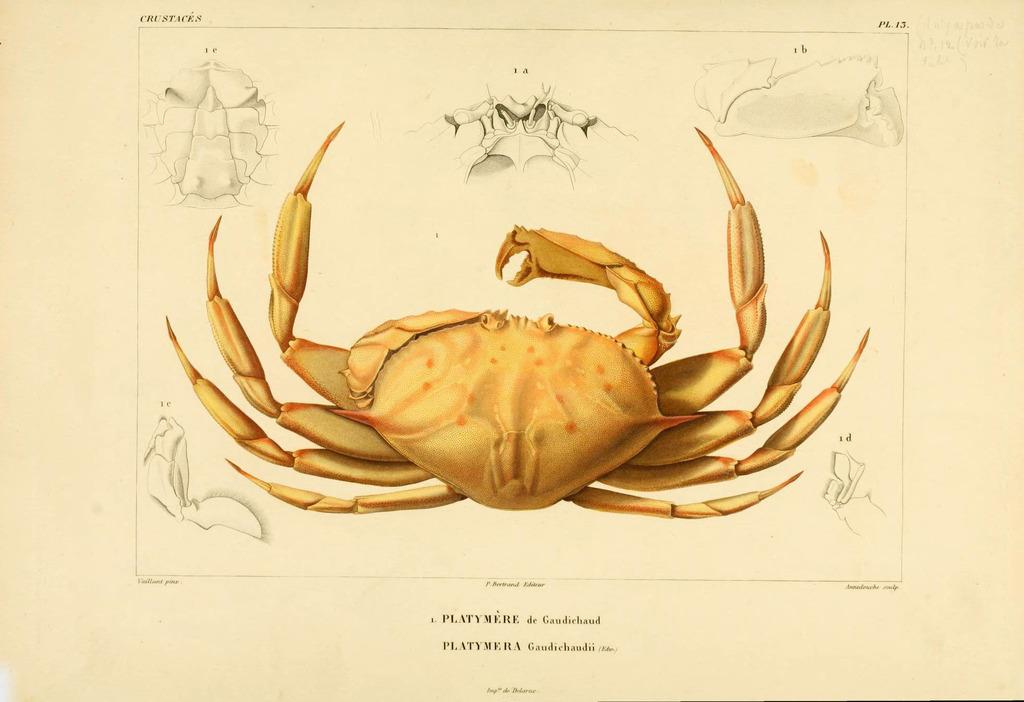What is present on the paper in the image? There are words, numbers, and images on the paper in the image. Can you describe the content of the paper? The paper contains a combination of words, numbers, and images. What type of railway is visible in the image? There is no railway present in the image; it only features a paper with words, numbers, and images. Can you tell me how many eggs are on the paper in the image? There are no eggs present on the paper in the image. 